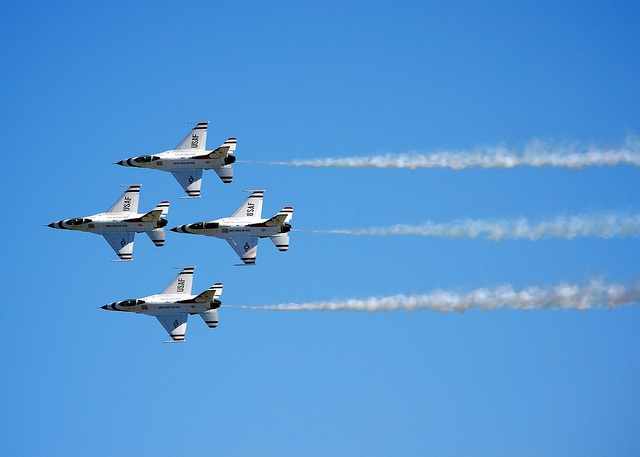Describe the objects in this image and their specific colors. I can see airplane in gray, lightgray, lightblue, and blue tones, airplane in gray, lightgray, black, and lightblue tones, airplane in gray, lightgray, black, and blue tones, and airplane in gray, white, and black tones in this image. 